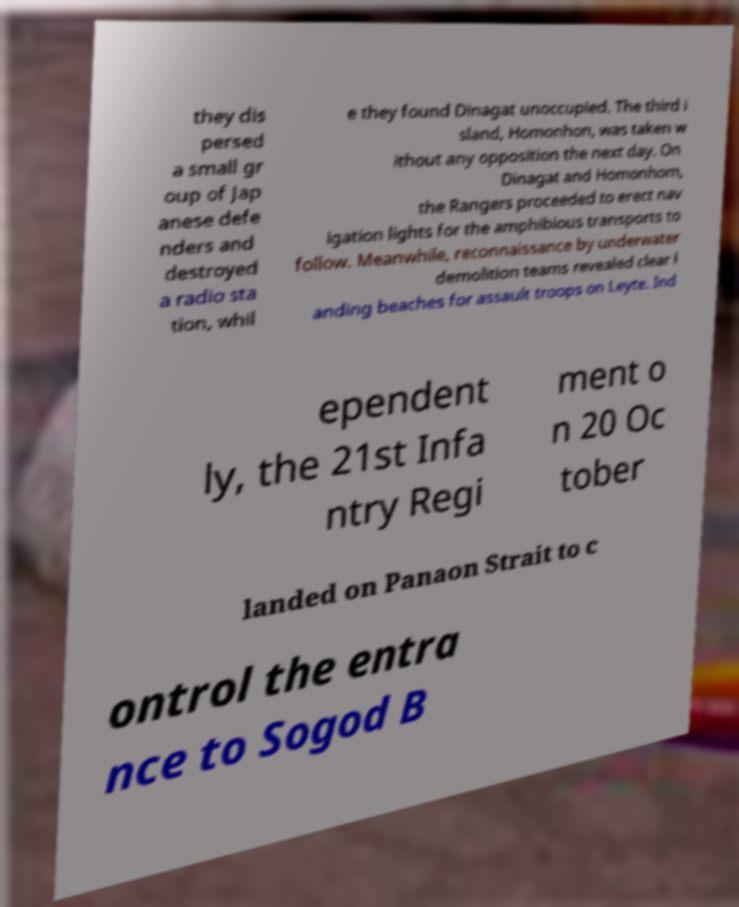Could you extract and type out the text from this image? they dis persed a small gr oup of Jap anese defe nders and destroyed a radio sta tion, whil e they found Dinagat unoccupied. The third i sland, Homonhon, was taken w ithout any opposition the next day. On Dinagat and Homonhom, the Rangers proceeded to erect nav igation lights for the amphibious transports to follow. Meanwhile, reconnaissance by underwater demolition teams revealed clear l anding beaches for assault troops on Leyte. Ind ependent ly, the 21st Infa ntry Regi ment o n 20 Oc tober landed on Panaon Strait to c ontrol the entra nce to Sogod B 